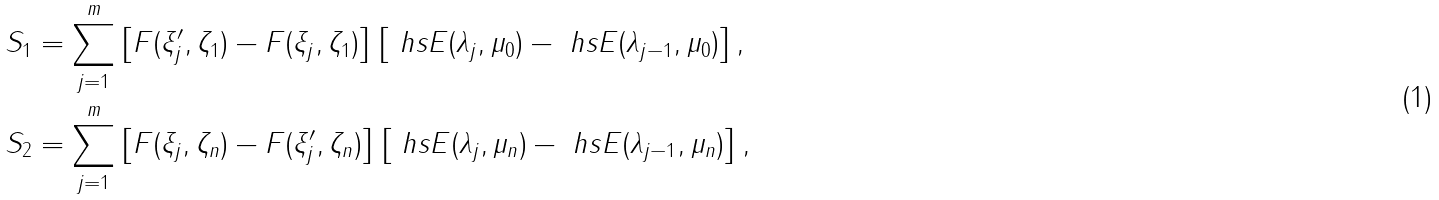Convert formula to latex. <formula><loc_0><loc_0><loc_500><loc_500>S _ { 1 } & = \sum _ { j = 1 } ^ { m } \left [ F ( \xi ^ { \prime } _ { j } , \zeta _ { 1 } ) - F ( \xi _ { j } , \zeta _ { 1 } ) \right ] \left [ \ h s E ( \lambda _ { j } , \mu _ { 0 } ) - \ h s E ( \lambda _ { j - 1 } , \mu _ { 0 } ) \right ] , \\ S _ { 2 } & = \sum _ { j = 1 } ^ { m } \left [ F ( \xi _ { j } , \zeta _ { n } ) - F ( \xi ^ { \prime } _ { j } , \zeta _ { n } ) \right ] \left [ \ h s E ( \lambda _ { j } , \mu _ { n } ) - \ h s E ( \lambda _ { j - 1 } , \mu _ { n } ) \right ] ,</formula> 